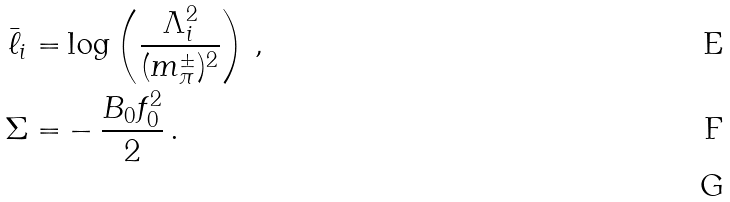<formula> <loc_0><loc_0><loc_500><loc_500>\bar { \ell } _ { i } = & \log \left ( \frac { \Lambda _ { i } ^ { 2 } } { ( m _ { \pi } ^ { \pm } ) ^ { 2 } } \right ) \, , \\ \Sigma = & - \frac { B _ { 0 } f _ { 0 } ^ { 2 } } { 2 } \, . \\</formula> 